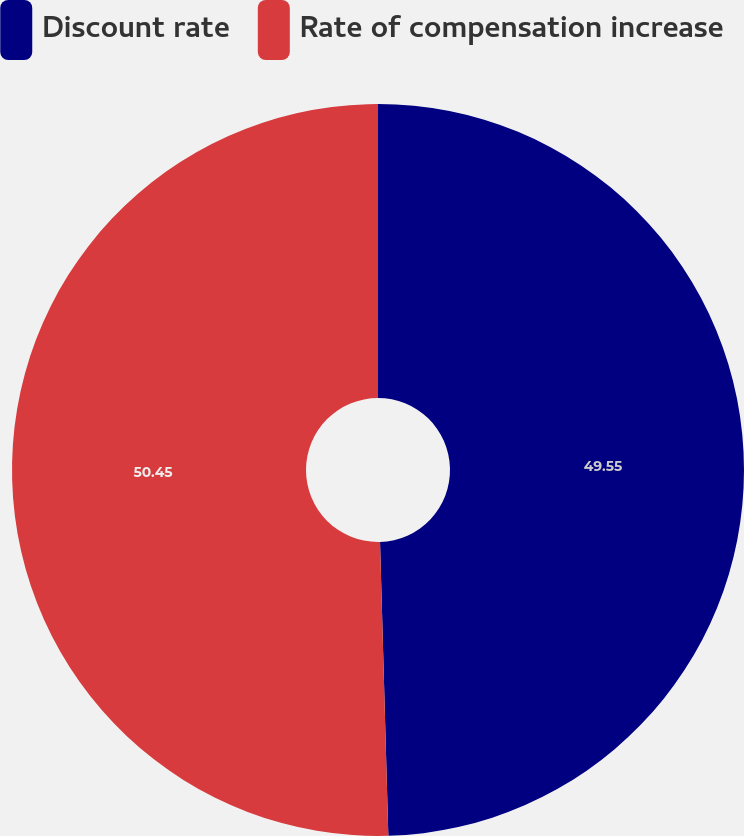Convert chart. <chart><loc_0><loc_0><loc_500><loc_500><pie_chart><fcel>Discount rate<fcel>Rate of compensation increase<nl><fcel>49.55%<fcel>50.45%<nl></chart> 